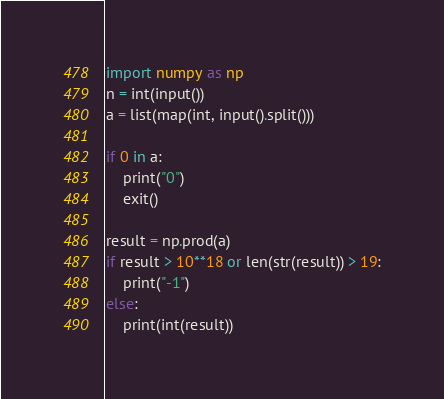<code> <loc_0><loc_0><loc_500><loc_500><_Python_>import numpy as np
n = int(input())
a = list(map(int, input().split()))

if 0 in a:
    print("0")
    exit()

result = np.prod(a)
if result > 10**18 or len(str(result)) > 19:
    print("-1")
else:
    print(int(result))</code> 